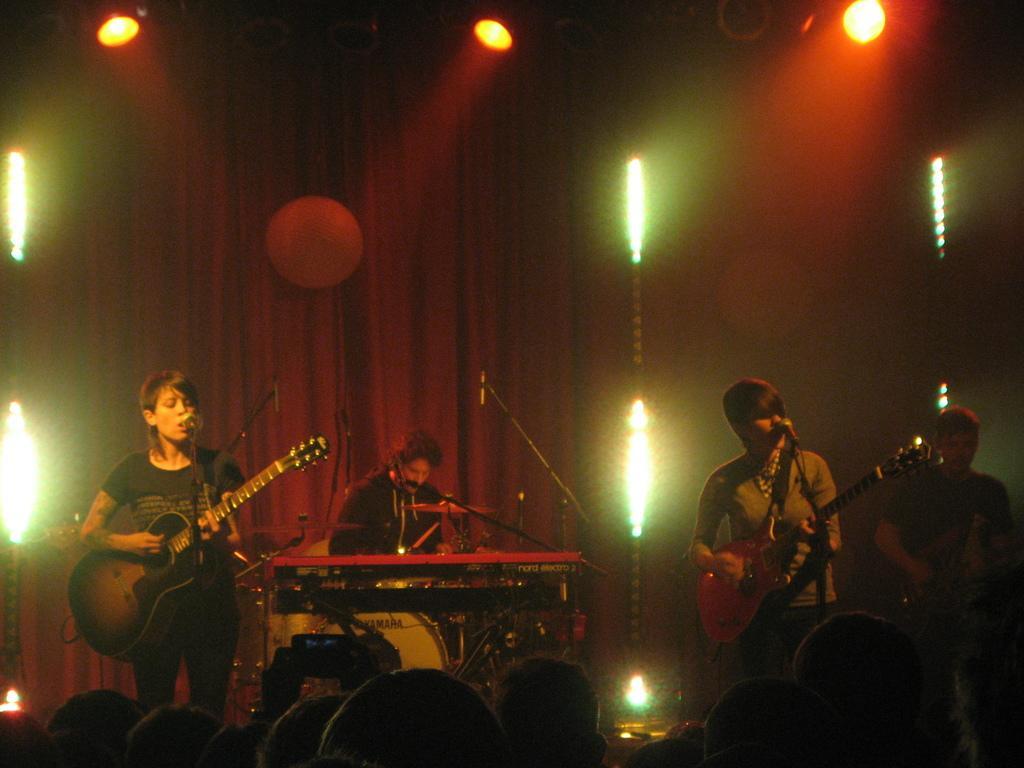Can you describe this image briefly? It looks like a stage performance. There are two persons standing and playing guitar along with that they are singing a song. At background I can see a man sitting and playing drums. At the right corner of the image I can a person standing and holding some musical instrument. These are the audience watching the performance. At background there is a red cloth hanging with a show lights. 